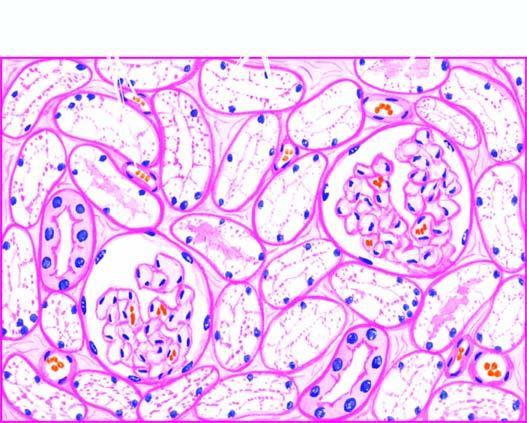what is compressed?
Answer the question using a single word or phrase. Interstitial vasculature 